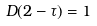<formula> <loc_0><loc_0><loc_500><loc_500>D ( 2 - \tau ) = 1</formula> 